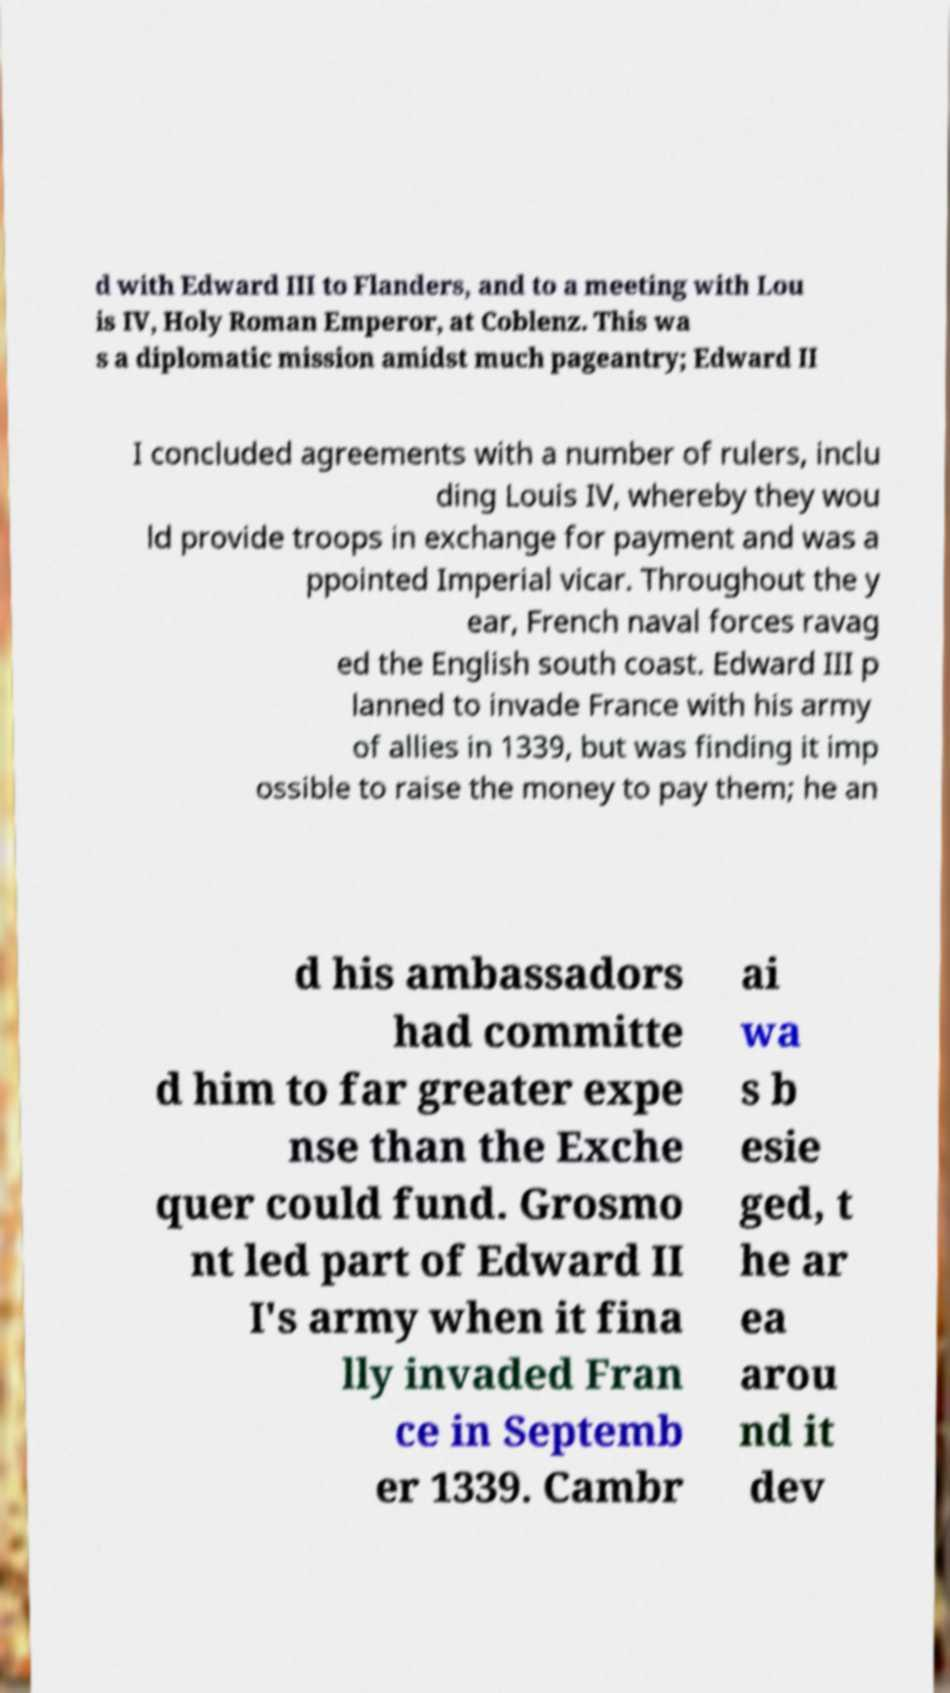Please read and relay the text visible in this image. What does it say? d with Edward III to Flanders, and to a meeting with Lou is IV, Holy Roman Emperor, at Coblenz. This wa s a diplomatic mission amidst much pageantry; Edward II I concluded agreements with a number of rulers, inclu ding Louis IV, whereby they wou ld provide troops in exchange for payment and was a ppointed Imperial vicar. Throughout the y ear, French naval forces ravag ed the English south coast. Edward III p lanned to invade France with his army of allies in 1339, but was finding it imp ossible to raise the money to pay them; he an d his ambassadors had committe d him to far greater expe nse than the Exche quer could fund. Grosmo nt led part of Edward II I's army when it fina lly invaded Fran ce in Septemb er 1339. Cambr ai wa s b esie ged, t he ar ea arou nd it dev 